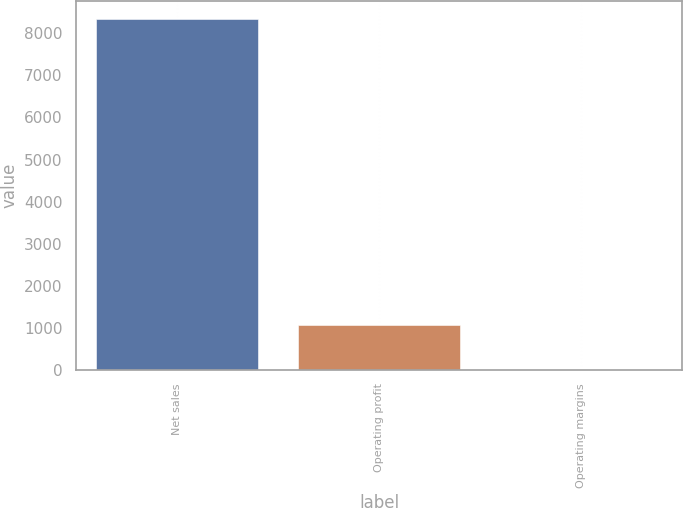Convert chart. <chart><loc_0><loc_0><loc_500><loc_500><bar_chart><fcel>Net sales<fcel>Operating profit<fcel>Operating margins<nl><fcel>8347<fcel>1083<fcel>13<nl></chart> 